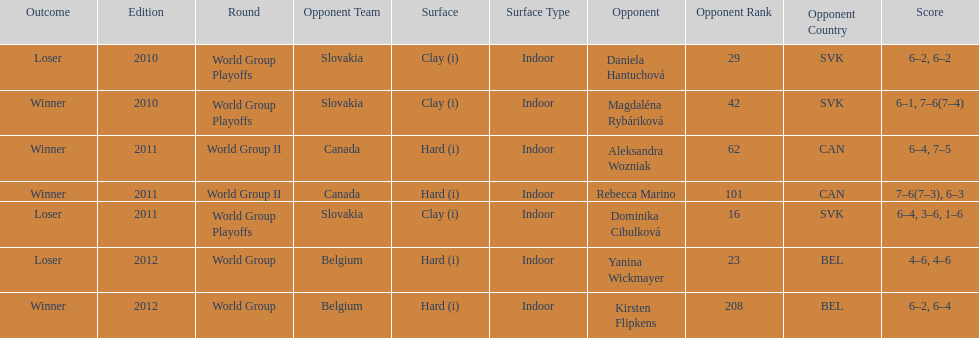Did they beat canada in more or less than 3 matches? Less. 